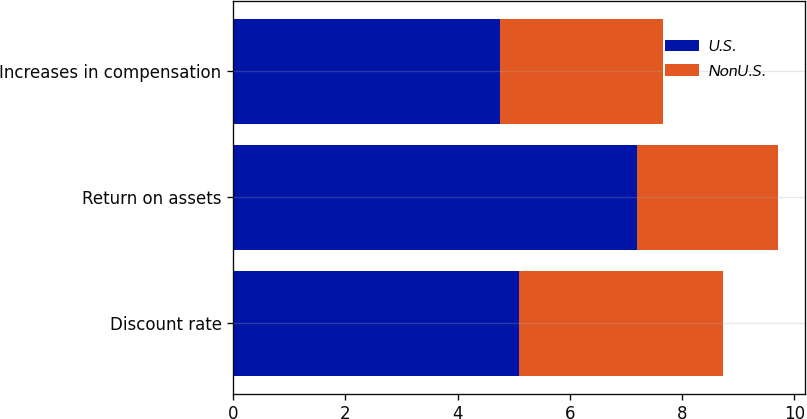<chart> <loc_0><loc_0><loc_500><loc_500><stacked_bar_chart><ecel><fcel>Discount rate<fcel>Return on assets<fcel>Increases in compensation<nl><fcel>U.S.<fcel>5.1<fcel>7.2<fcel>4.75<nl><fcel>NonU.S.<fcel>3.63<fcel>2.5<fcel>2.9<nl></chart> 